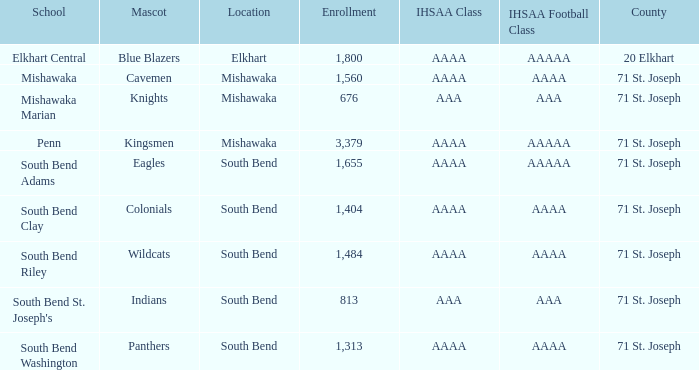In south bend, which academic establishment has indians as their mascot? South Bend St. Joseph's. 